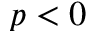<formula> <loc_0><loc_0><loc_500><loc_500>p < 0</formula> 